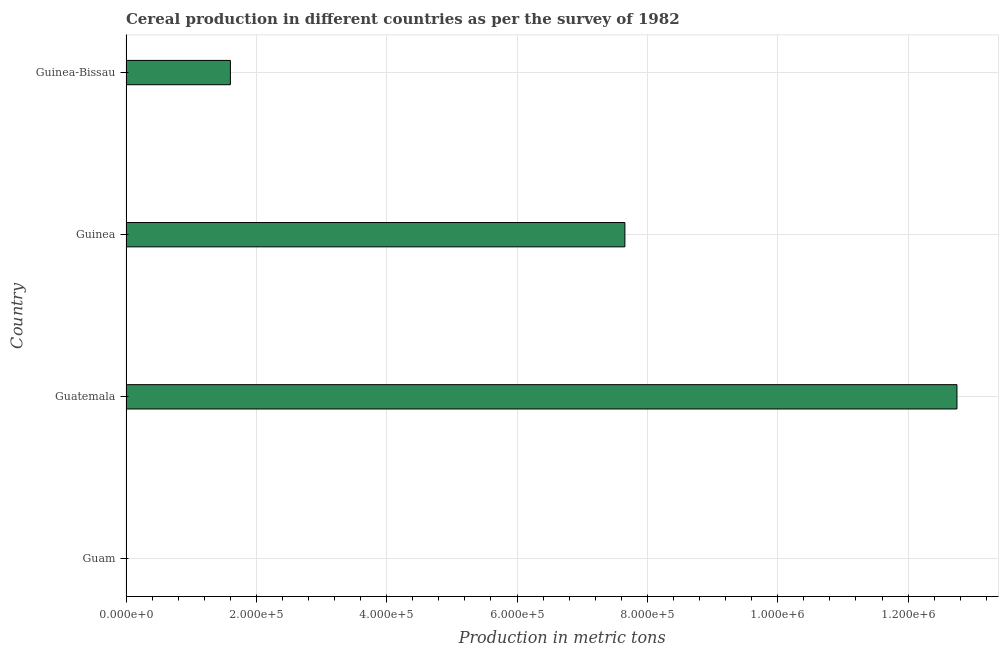Does the graph contain any zero values?
Your response must be concise. No. What is the title of the graph?
Keep it short and to the point. Cereal production in different countries as per the survey of 1982. What is the label or title of the X-axis?
Provide a succinct answer. Production in metric tons. What is the label or title of the Y-axis?
Ensure brevity in your answer.  Country. What is the cereal production in Guatemala?
Your answer should be compact. 1.27e+06. Across all countries, what is the maximum cereal production?
Your answer should be very brief. 1.27e+06. Across all countries, what is the minimum cereal production?
Provide a short and direct response. 30. In which country was the cereal production maximum?
Ensure brevity in your answer.  Guatemala. In which country was the cereal production minimum?
Make the answer very short. Guam. What is the sum of the cereal production?
Ensure brevity in your answer.  2.20e+06. What is the difference between the cereal production in Guinea and Guinea-Bissau?
Provide a short and direct response. 6.05e+05. What is the average cereal production per country?
Your answer should be very brief. 5.50e+05. What is the median cereal production?
Provide a short and direct response. 4.63e+05. In how many countries, is the cereal production greater than 1120000 metric tons?
Offer a terse response. 1. What is the ratio of the cereal production in Guam to that in Guatemala?
Offer a very short reply. 0. Is the cereal production in Guatemala less than that in Guinea-Bissau?
Make the answer very short. No. What is the difference between the highest and the second highest cereal production?
Ensure brevity in your answer.  5.09e+05. What is the difference between the highest and the lowest cereal production?
Give a very brief answer. 1.27e+06. In how many countries, is the cereal production greater than the average cereal production taken over all countries?
Provide a short and direct response. 2. Are the values on the major ticks of X-axis written in scientific E-notation?
Offer a very short reply. Yes. What is the Production in metric tons of Guam?
Offer a very short reply. 30. What is the Production in metric tons in Guatemala?
Your response must be concise. 1.27e+06. What is the Production in metric tons in Guinea?
Give a very brief answer. 7.65e+05. What is the Production in metric tons of Guinea-Bissau?
Your response must be concise. 1.60e+05. What is the difference between the Production in metric tons in Guam and Guatemala?
Your answer should be very brief. -1.27e+06. What is the difference between the Production in metric tons in Guam and Guinea?
Provide a succinct answer. -7.65e+05. What is the difference between the Production in metric tons in Guam and Guinea-Bissau?
Ensure brevity in your answer.  -1.60e+05. What is the difference between the Production in metric tons in Guatemala and Guinea?
Keep it short and to the point. 5.09e+05. What is the difference between the Production in metric tons in Guatemala and Guinea-Bissau?
Your response must be concise. 1.11e+06. What is the difference between the Production in metric tons in Guinea and Guinea-Bissau?
Offer a terse response. 6.05e+05. What is the ratio of the Production in metric tons in Guatemala to that in Guinea?
Ensure brevity in your answer.  1.67. What is the ratio of the Production in metric tons in Guatemala to that in Guinea-Bissau?
Offer a terse response. 7.96. What is the ratio of the Production in metric tons in Guinea to that in Guinea-Bissau?
Ensure brevity in your answer.  4.78. 